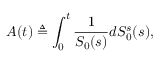Convert formula to latex. <formula><loc_0><loc_0><loc_500><loc_500>A ( t ) \triangle q \int _ { 0 } ^ { t } { \frac { 1 } { S _ { 0 } ( s ) } } d S _ { 0 } ^ { s } ( s ) ,</formula> 